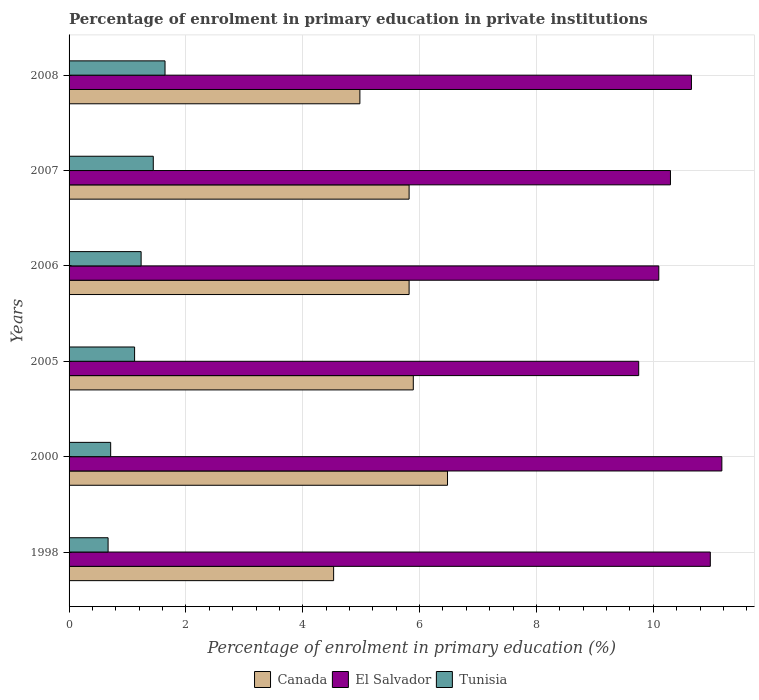How many different coloured bars are there?
Make the answer very short. 3. How many groups of bars are there?
Offer a terse response. 6. Are the number of bars on each tick of the Y-axis equal?
Offer a very short reply. Yes. What is the label of the 2nd group of bars from the top?
Ensure brevity in your answer.  2007. What is the percentage of enrolment in primary education in Tunisia in 2007?
Offer a terse response. 1.44. Across all years, what is the maximum percentage of enrolment in primary education in El Salvador?
Make the answer very short. 11.17. Across all years, what is the minimum percentage of enrolment in primary education in Canada?
Offer a terse response. 4.53. What is the total percentage of enrolment in primary education in El Salvador in the graph?
Make the answer very short. 62.94. What is the difference between the percentage of enrolment in primary education in Canada in 2000 and that in 2005?
Give a very brief answer. 0.59. What is the difference between the percentage of enrolment in primary education in Canada in 2006 and the percentage of enrolment in primary education in Tunisia in 2000?
Ensure brevity in your answer.  5.11. What is the average percentage of enrolment in primary education in Tunisia per year?
Your response must be concise. 1.14. In the year 2008, what is the difference between the percentage of enrolment in primary education in Tunisia and percentage of enrolment in primary education in Canada?
Make the answer very short. -3.34. What is the ratio of the percentage of enrolment in primary education in Tunisia in 1998 to that in 2007?
Keep it short and to the point. 0.46. Is the percentage of enrolment in primary education in El Salvador in 1998 less than that in 2006?
Keep it short and to the point. No. What is the difference between the highest and the second highest percentage of enrolment in primary education in Tunisia?
Your answer should be very brief. 0.2. What is the difference between the highest and the lowest percentage of enrolment in primary education in Canada?
Make the answer very short. 1.95. In how many years, is the percentage of enrolment in primary education in Tunisia greater than the average percentage of enrolment in primary education in Tunisia taken over all years?
Make the answer very short. 3. What does the 3rd bar from the top in 2005 represents?
Provide a short and direct response. Canada. What does the 2nd bar from the bottom in 2005 represents?
Your answer should be very brief. El Salvador. How many bars are there?
Keep it short and to the point. 18. Does the graph contain any zero values?
Offer a terse response. No. Where does the legend appear in the graph?
Provide a succinct answer. Bottom center. How are the legend labels stacked?
Give a very brief answer. Horizontal. What is the title of the graph?
Provide a succinct answer. Percentage of enrolment in primary education in private institutions. What is the label or title of the X-axis?
Make the answer very short. Percentage of enrolment in primary education (%). What is the Percentage of enrolment in primary education (%) in Canada in 1998?
Make the answer very short. 4.53. What is the Percentage of enrolment in primary education (%) in El Salvador in 1998?
Offer a terse response. 10.98. What is the Percentage of enrolment in primary education (%) in Tunisia in 1998?
Your answer should be compact. 0.67. What is the Percentage of enrolment in primary education (%) in Canada in 2000?
Your answer should be compact. 6.48. What is the Percentage of enrolment in primary education (%) in El Salvador in 2000?
Make the answer very short. 11.17. What is the Percentage of enrolment in primary education (%) of Tunisia in 2000?
Make the answer very short. 0.71. What is the Percentage of enrolment in primary education (%) in Canada in 2005?
Your answer should be compact. 5.89. What is the Percentage of enrolment in primary education (%) in El Salvador in 2005?
Provide a succinct answer. 9.75. What is the Percentage of enrolment in primary education (%) of Tunisia in 2005?
Your answer should be compact. 1.12. What is the Percentage of enrolment in primary education (%) of Canada in 2006?
Keep it short and to the point. 5.82. What is the Percentage of enrolment in primary education (%) in El Salvador in 2006?
Make the answer very short. 10.09. What is the Percentage of enrolment in primary education (%) in Tunisia in 2006?
Your answer should be compact. 1.23. What is the Percentage of enrolment in primary education (%) in Canada in 2007?
Make the answer very short. 5.82. What is the Percentage of enrolment in primary education (%) in El Salvador in 2007?
Provide a short and direct response. 10.29. What is the Percentage of enrolment in primary education (%) of Tunisia in 2007?
Your response must be concise. 1.44. What is the Percentage of enrolment in primary education (%) in Canada in 2008?
Your answer should be compact. 4.98. What is the Percentage of enrolment in primary education (%) of El Salvador in 2008?
Make the answer very short. 10.65. What is the Percentage of enrolment in primary education (%) in Tunisia in 2008?
Your answer should be very brief. 1.64. Across all years, what is the maximum Percentage of enrolment in primary education (%) in Canada?
Your answer should be compact. 6.48. Across all years, what is the maximum Percentage of enrolment in primary education (%) of El Salvador?
Your response must be concise. 11.17. Across all years, what is the maximum Percentage of enrolment in primary education (%) in Tunisia?
Offer a terse response. 1.64. Across all years, what is the minimum Percentage of enrolment in primary education (%) of Canada?
Offer a very short reply. 4.53. Across all years, what is the minimum Percentage of enrolment in primary education (%) in El Salvador?
Keep it short and to the point. 9.75. Across all years, what is the minimum Percentage of enrolment in primary education (%) of Tunisia?
Provide a short and direct response. 0.67. What is the total Percentage of enrolment in primary education (%) of Canada in the graph?
Ensure brevity in your answer.  33.52. What is the total Percentage of enrolment in primary education (%) in El Salvador in the graph?
Offer a very short reply. 62.94. What is the total Percentage of enrolment in primary education (%) of Tunisia in the graph?
Your answer should be compact. 6.82. What is the difference between the Percentage of enrolment in primary education (%) of Canada in 1998 and that in 2000?
Keep it short and to the point. -1.95. What is the difference between the Percentage of enrolment in primary education (%) of El Salvador in 1998 and that in 2000?
Ensure brevity in your answer.  -0.2. What is the difference between the Percentage of enrolment in primary education (%) of Tunisia in 1998 and that in 2000?
Provide a short and direct response. -0.04. What is the difference between the Percentage of enrolment in primary education (%) in Canada in 1998 and that in 2005?
Make the answer very short. -1.36. What is the difference between the Percentage of enrolment in primary education (%) in El Salvador in 1998 and that in 2005?
Your answer should be compact. 1.23. What is the difference between the Percentage of enrolment in primary education (%) in Tunisia in 1998 and that in 2005?
Offer a terse response. -0.45. What is the difference between the Percentage of enrolment in primary education (%) of Canada in 1998 and that in 2006?
Offer a very short reply. -1.29. What is the difference between the Percentage of enrolment in primary education (%) in El Salvador in 1998 and that in 2006?
Keep it short and to the point. 0.88. What is the difference between the Percentage of enrolment in primary education (%) of Tunisia in 1998 and that in 2006?
Offer a terse response. -0.57. What is the difference between the Percentage of enrolment in primary education (%) of Canada in 1998 and that in 2007?
Offer a terse response. -1.29. What is the difference between the Percentage of enrolment in primary education (%) in El Salvador in 1998 and that in 2007?
Your answer should be compact. 0.68. What is the difference between the Percentage of enrolment in primary education (%) in Tunisia in 1998 and that in 2007?
Keep it short and to the point. -0.77. What is the difference between the Percentage of enrolment in primary education (%) in Canada in 1998 and that in 2008?
Ensure brevity in your answer.  -0.45. What is the difference between the Percentage of enrolment in primary education (%) in El Salvador in 1998 and that in 2008?
Your response must be concise. 0.32. What is the difference between the Percentage of enrolment in primary education (%) in Tunisia in 1998 and that in 2008?
Make the answer very short. -0.97. What is the difference between the Percentage of enrolment in primary education (%) of Canada in 2000 and that in 2005?
Provide a succinct answer. 0.59. What is the difference between the Percentage of enrolment in primary education (%) of El Salvador in 2000 and that in 2005?
Your answer should be very brief. 1.42. What is the difference between the Percentage of enrolment in primary education (%) in Tunisia in 2000 and that in 2005?
Give a very brief answer. -0.41. What is the difference between the Percentage of enrolment in primary education (%) of Canada in 2000 and that in 2006?
Your answer should be very brief. 0.66. What is the difference between the Percentage of enrolment in primary education (%) of El Salvador in 2000 and that in 2006?
Give a very brief answer. 1.08. What is the difference between the Percentage of enrolment in primary education (%) of Tunisia in 2000 and that in 2006?
Provide a succinct answer. -0.52. What is the difference between the Percentage of enrolment in primary education (%) of Canada in 2000 and that in 2007?
Offer a terse response. 0.66. What is the difference between the Percentage of enrolment in primary education (%) in El Salvador in 2000 and that in 2007?
Your answer should be very brief. 0.88. What is the difference between the Percentage of enrolment in primary education (%) of Tunisia in 2000 and that in 2007?
Provide a short and direct response. -0.73. What is the difference between the Percentage of enrolment in primary education (%) in Canada in 2000 and that in 2008?
Make the answer very short. 1.5. What is the difference between the Percentage of enrolment in primary education (%) of El Salvador in 2000 and that in 2008?
Your answer should be very brief. 0.52. What is the difference between the Percentage of enrolment in primary education (%) in Tunisia in 2000 and that in 2008?
Give a very brief answer. -0.93. What is the difference between the Percentage of enrolment in primary education (%) of Canada in 2005 and that in 2006?
Your response must be concise. 0.07. What is the difference between the Percentage of enrolment in primary education (%) of El Salvador in 2005 and that in 2006?
Provide a short and direct response. -0.34. What is the difference between the Percentage of enrolment in primary education (%) in Tunisia in 2005 and that in 2006?
Keep it short and to the point. -0.11. What is the difference between the Percentage of enrolment in primary education (%) in Canada in 2005 and that in 2007?
Provide a succinct answer. 0.07. What is the difference between the Percentage of enrolment in primary education (%) of El Salvador in 2005 and that in 2007?
Give a very brief answer. -0.54. What is the difference between the Percentage of enrolment in primary education (%) in Tunisia in 2005 and that in 2007?
Offer a terse response. -0.32. What is the difference between the Percentage of enrolment in primary education (%) of Canada in 2005 and that in 2008?
Give a very brief answer. 0.91. What is the difference between the Percentage of enrolment in primary education (%) of El Salvador in 2005 and that in 2008?
Provide a succinct answer. -0.9. What is the difference between the Percentage of enrolment in primary education (%) of Tunisia in 2005 and that in 2008?
Give a very brief answer. -0.52. What is the difference between the Percentage of enrolment in primary education (%) in El Salvador in 2006 and that in 2007?
Ensure brevity in your answer.  -0.2. What is the difference between the Percentage of enrolment in primary education (%) of Tunisia in 2006 and that in 2007?
Provide a short and direct response. -0.21. What is the difference between the Percentage of enrolment in primary education (%) in Canada in 2006 and that in 2008?
Your response must be concise. 0.84. What is the difference between the Percentage of enrolment in primary education (%) of El Salvador in 2006 and that in 2008?
Your answer should be very brief. -0.56. What is the difference between the Percentage of enrolment in primary education (%) in Tunisia in 2006 and that in 2008?
Make the answer very short. -0.41. What is the difference between the Percentage of enrolment in primary education (%) in Canada in 2007 and that in 2008?
Your response must be concise. 0.84. What is the difference between the Percentage of enrolment in primary education (%) of El Salvador in 2007 and that in 2008?
Offer a very short reply. -0.36. What is the difference between the Percentage of enrolment in primary education (%) of Tunisia in 2007 and that in 2008?
Your answer should be compact. -0.2. What is the difference between the Percentage of enrolment in primary education (%) of Canada in 1998 and the Percentage of enrolment in primary education (%) of El Salvador in 2000?
Offer a terse response. -6.65. What is the difference between the Percentage of enrolment in primary education (%) in Canada in 1998 and the Percentage of enrolment in primary education (%) in Tunisia in 2000?
Provide a short and direct response. 3.82. What is the difference between the Percentage of enrolment in primary education (%) in El Salvador in 1998 and the Percentage of enrolment in primary education (%) in Tunisia in 2000?
Your answer should be compact. 10.26. What is the difference between the Percentage of enrolment in primary education (%) of Canada in 1998 and the Percentage of enrolment in primary education (%) of El Salvador in 2005?
Offer a terse response. -5.22. What is the difference between the Percentage of enrolment in primary education (%) of Canada in 1998 and the Percentage of enrolment in primary education (%) of Tunisia in 2005?
Provide a succinct answer. 3.41. What is the difference between the Percentage of enrolment in primary education (%) of El Salvador in 1998 and the Percentage of enrolment in primary education (%) of Tunisia in 2005?
Provide a short and direct response. 9.85. What is the difference between the Percentage of enrolment in primary education (%) of Canada in 1998 and the Percentage of enrolment in primary education (%) of El Salvador in 2006?
Provide a succinct answer. -5.57. What is the difference between the Percentage of enrolment in primary education (%) of Canada in 1998 and the Percentage of enrolment in primary education (%) of Tunisia in 2006?
Give a very brief answer. 3.29. What is the difference between the Percentage of enrolment in primary education (%) of El Salvador in 1998 and the Percentage of enrolment in primary education (%) of Tunisia in 2006?
Keep it short and to the point. 9.74. What is the difference between the Percentage of enrolment in primary education (%) of Canada in 1998 and the Percentage of enrolment in primary education (%) of El Salvador in 2007?
Offer a very short reply. -5.77. What is the difference between the Percentage of enrolment in primary education (%) in Canada in 1998 and the Percentage of enrolment in primary education (%) in Tunisia in 2007?
Your answer should be very brief. 3.09. What is the difference between the Percentage of enrolment in primary education (%) in El Salvador in 1998 and the Percentage of enrolment in primary education (%) in Tunisia in 2007?
Your answer should be very brief. 9.53. What is the difference between the Percentage of enrolment in primary education (%) of Canada in 1998 and the Percentage of enrolment in primary education (%) of El Salvador in 2008?
Make the answer very short. -6.12. What is the difference between the Percentage of enrolment in primary education (%) in Canada in 1998 and the Percentage of enrolment in primary education (%) in Tunisia in 2008?
Your response must be concise. 2.89. What is the difference between the Percentage of enrolment in primary education (%) of El Salvador in 1998 and the Percentage of enrolment in primary education (%) of Tunisia in 2008?
Provide a short and direct response. 9.33. What is the difference between the Percentage of enrolment in primary education (%) in Canada in 2000 and the Percentage of enrolment in primary education (%) in El Salvador in 2005?
Ensure brevity in your answer.  -3.27. What is the difference between the Percentage of enrolment in primary education (%) of Canada in 2000 and the Percentage of enrolment in primary education (%) of Tunisia in 2005?
Your answer should be very brief. 5.36. What is the difference between the Percentage of enrolment in primary education (%) of El Salvador in 2000 and the Percentage of enrolment in primary education (%) of Tunisia in 2005?
Your answer should be very brief. 10.05. What is the difference between the Percentage of enrolment in primary education (%) in Canada in 2000 and the Percentage of enrolment in primary education (%) in El Salvador in 2006?
Your answer should be very brief. -3.62. What is the difference between the Percentage of enrolment in primary education (%) in Canada in 2000 and the Percentage of enrolment in primary education (%) in Tunisia in 2006?
Your response must be concise. 5.24. What is the difference between the Percentage of enrolment in primary education (%) in El Salvador in 2000 and the Percentage of enrolment in primary education (%) in Tunisia in 2006?
Your answer should be very brief. 9.94. What is the difference between the Percentage of enrolment in primary education (%) in Canada in 2000 and the Percentage of enrolment in primary education (%) in El Salvador in 2007?
Your answer should be compact. -3.82. What is the difference between the Percentage of enrolment in primary education (%) in Canada in 2000 and the Percentage of enrolment in primary education (%) in Tunisia in 2007?
Ensure brevity in your answer.  5.04. What is the difference between the Percentage of enrolment in primary education (%) of El Salvador in 2000 and the Percentage of enrolment in primary education (%) of Tunisia in 2007?
Provide a succinct answer. 9.73. What is the difference between the Percentage of enrolment in primary education (%) in Canada in 2000 and the Percentage of enrolment in primary education (%) in El Salvador in 2008?
Offer a very short reply. -4.18. What is the difference between the Percentage of enrolment in primary education (%) of Canada in 2000 and the Percentage of enrolment in primary education (%) of Tunisia in 2008?
Make the answer very short. 4.84. What is the difference between the Percentage of enrolment in primary education (%) of El Salvador in 2000 and the Percentage of enrolment in primary education (%) of Tunisia in 2008?
Keep it short and to the point. 9.53. What is the difference between the Percentage of enrolment in primary education (%) of Canada in 2005 and the Percentage of enrolment in primary education (%) of El Salvador in 2006?
Offer a terse response. -4.2. What is the difference between the Percentage of enrolment in primary education (%) in Canada in 2005 and the Percentage of enrolment in primary education (%) in Tunisia in 2006?
Your response must be concise. 4.66. What is the difference between the Percentage of enrolment in primary education (%) in El Salvador in 2005 and the Percentage of enrolment in primary education (%) in Tunisia in 2006?
Provide a short and direct response. 8.52. What is the difference between the Percentage of enrolment in primary education (%) of Canada in 2005 and the Percentage of enrolment in primary education (%) of El Salvador in 2007?
Your answer should be compact. -4.4. What is the difference between the Percentage of enrolment in primary education (%) in Canada in 2005 and the Percentage of enrolment in primary education (%) in Tunisia in 2007?
Your answer should be very brief. 4.45. What is the difference between the Percentage of enrolment in primary education (%) of El Salvador in 2005 and the Percentage of enrolment in primary education (%) of Tunisia in 2007?
Provide a short and direct response. 8.31. What is the difference between the Percentage of enrolment in primary education (%) in Canada in 2005 and the Percentage of enrolment in primary education (%) in El Salvador in 2008?
Your answer should be compact. -4.76. What is the difference between the Percentage of enrolment in primary education (%) of Canada in 2005 and the Percentage of enrolment in primary education (%) of Tunisia in 2008?
Your response must be concise. 4.25. What is the difference between the Percentage of enrolment in primary education (%) in El Salvador in 2005 and the Percentage of enrolment in primary education (%) in Tunisia in 2008?
Make the answer very short. 8.11. What is the difference between the Percentage of enrolment in primary education (%) in Canada in 2006 and the Percentage of enrolment in primary education (%) in El Salvador in 2007?
Your response must be concise. -4.47. What is the difference between the Percentage of enrolment in primary education (%) of Canada in 2006 and the Percentage of enrolment in primary education (%) of Tunisia in 2007?
Keep it short and to the point. 4.38. What is the difference between the Percentage of enrolment in primary education (%) of El Salvador in 2006 and the Percentage of enrolment in primary education (%) of Tunisia in 2007?
Provide a short and direct response. 8.65. What is the difference between the Percentage of enrolment in primary education (%) in Canada in 2006 and the Percentage of enrolment in primary education (%) in El Salvador in 2008?
Provide a succinct answer. -4.83. What is the difference between the Percentage of enrolment in primary education (%) of Canada in 2006 and the Percentage of enrolment in primary education (%) of Tunisia in 2008?
Give a very brief answer. 4.18. What is the difference between the Percentage of enrolment in primary education (%) of El Salvador in 2006 and the Percentage of enrolment in primary education (%) of Tunisia in 2008?
Provide a succinct answer. 8.45. What is the difference between the Percentage of enrolment in primary education (%) of Canada in 2007 and the Percentage of enrolment in primary education (%) of El Salvador in 2008?
Your answer should be very brief. -4.83. What is the difference between the Percentage of enrolment in primary education (%) of Canada in 2007 and the Percentage of enrolment in primary education (%) of Tunisia in 2008?
Your response must be concise. 4.18. What is the difference between the Percentage of enrolment in primary education (%) of El Salvador in 2007 and the Percentage of enrolment in primary education (%) of Tunisia in 2008?
Make the answer very short. 8.65. What is the average Percentage of enrolment in primary education (%) in Canada per year?
Keep it short and to the point. 5.59. What is the average Percentage of enrolment in primary education (%) in El Salvador per year?
Provide a succinct answer. 10.49. What is the average Percentage of enrolment in primary education (%) in Tunisia per year?
Make the answer very short. 1.14. In the year 1998, what is the difference between the Percentage of enrolment in primary education (%) of Canada and Percentage of enrolment in primary education (%) of El Salvador?
Offer a terse response. -6.45. In the year 1998, what is the difference between the Percentage of enrolment in primary education (%) of Canada and Percentage of enrolment in primary education (%) of Tunisia?
Give a very brief answer. 3.86. In the year 1998, what is the difference between the Percentage of enrolment in primary education (%) in El Salvador and Percentage of enrolment in primary education (%) in Tunisia?
Give a very brief answer. 10.31. In the year 2000, what is the difference between the Percentage of enrolment in primary education (%) of Canada and Percentage of enrolment in primary education (%) of El Salvador?
Provide a succinct answer. -4.7. In the year 2000, what is the difference between the Percentage of enrolment in primary education (%) of Canada and Percentage of enrolment in primary education (%) of Tunisia?
Your answer should be compact. 5.77. In the year 2000, what is the difference between the Percentage of enrolment in primary education (%) of El Salvador and Percentage of enrolment in primary education (%) of Tunisia?
Provide a short and direct response. 10.46. In the year 2005, what is the difference between the Percentage of enrolment in primary education (%) in Canada and Percentage of enrolment in primary education (%) in El Salvador?
Ensure brevity in your answer.  -3.86. In the year 2005, what is the difference between the Percentage of enrolment in primary education (%) in Canada and Percentage of enrolment in primary education (%) in Tunisia?
Your response must be concise. 4.77. In the year 2005, what is the difference between the Percentage of enrolment in primary education (%) of El Salvador and Percentage of enrolment in primary education (%) of Tunisia?
Keep it short and to the point. 8.63. In the year 2006, what is the difference between the Percentage of enrolment in primary education (%) in Canada and Percentage of enrolment in primary education (%) in El Salvador?
Ensure brevity in your answer.  -4.27. In the year 2006, what is the difference between the Percentage of enrolment in primary education (%) of Canada and Percentage of enrolment in primary education (%) of Tunisia?
Offer a very short reply. 4.59. In the year 2006, what is the difference between the Percentage of enrolment in primary education (%) in El Salvador and Percentage of enrolment in primary education (%) in Tunisia?
Your response must be concise. 8.86. In the year 2007, what is the difference between the Percentage of enrolment in primary education (%) of Canada and Percentage of enrolment in primary education (%) of El Salvador?
Offer a terse response. -4.47. In the year 2007, what is the difference between the Percentage of enrolment in primary education (%) in Canada and Percentage of enrolment in primary education (%) in Tunisia?
Your response must be concise. 4.38. In the year 2007, what is the difference between the Percentage of enrolment in primary education (%) in El Salvador and Percentage of enrolment in primary education (%) in Tunisia?
Your response must be concise. 8.85. In the year 2008, what is the difference between the Percentage of enrolment in primary education (%) in Canada and Percentage of enrolment in primary education (%) in El Salvador?
Offer a very short reply. -5.68. In the year 2008, what is the difference between the Percentage of enrolment in primary education (%) in Canada and Percentage of enrolment in primary education (%) in Tunisia?
Provide a short and direct response. 3.34. In the year 2008, what is the difference between the Percentage of enrolment in primary education (%) of El Salvador and Percentage of enrolment in primary education (%) of Tunisia?
Give a very brief answer. 9.01. What is the ratio of the Percentage of enrolment in primary education (%) in Canada in 1998 to that in 2000?
Provide a short and direct response. 0.7. What is the ratio of the Percentage of enrolment in primary education (%) of El Salvador in 1998 to that in 2000?
Offer a very short reply. 0.98. What is the ratio of the Percentage of enrolment in primary education (%) in Tunisia in 1998 to that in 2000?
Your response must be concise. 0.94. What is the ratio of the Percentage of enrolment in primary education (%) of Canada in 1998 to that in 2005?
Your answer should be compact. 0.77. What is the ratio of the Percentage of enrolment in primary education (%) of El Salvador in 1998 to that in 2005?
Provide a succinct answer. 1.13. What is the ratio of the Percentage of enrolment in primary education (%) of Tunisia in 1998 to that in 2005?
Offer a terse response. 0.6. What is the ratio of the Percentage of enrolment in primary education (%) in Canada in 1998 to that in 2006?
Your response must be concise. 0.78. What is the ratio of the Percentage of enrolment in primary education (%) of El Salvador in 1998 to that in 2006?
Offer a terse response. 1.09. What is the ratio of the Percentage of enrolment in primary education (%) in Tunisia in 1998 to that in 2006?
Provide a short and direct response. 0.54. What is the ratio of the Percentage of enrolment in primary education (%) in Canada in 1998 to that in 2007?
Your answer should be compact. 0.78. What is the ratio of the Percentage of enrolment in primary education (%) of El Salvador in 1998 to that in 2007?
Your answer should be very brief. 1.07. What is the ratio of the Percentage of enrolment in primary education (%) of Tunisia in 1998 to that in 2007?
Make the answer very short. 0.46. What is the ratio of the Percentage of enrolment in primary education (%) of Canada in 1998 to that in 2008?
Offer a very short reply. 0.91. What is the ratio of the Percentage of enrolment in primary education (%) of El Salvador in 1998 to that in 2008?
Keep it short and to the point. 1.03. What is the ratio of the Percentage of enrolment in primary education (%) of Tunisia in 1998 to that in 2008?
Keep it short and to the point. 0.41. What is the ratio of the Percentage of enrolment in primary education (%) in Canada in 2000 to that in 2005?
Offer a terse response. 1.1. What is the ratio of the Percentage of enrolment in primary education (%) of El Salvador in 2000 to that in 2005?
Make the answer very short. 1.15. What is the ratio of the Percentage of enrolment in primary education (%) of Tunisia in 2000 to that in 2005?
Provide a short and direct response. 0.63. What is the ratio of the Percentage of enrolment in primary education (%) in Canada in 2000 to that in 2006?
Make the answer very short. 1.11. What is the ratio of the Percentage of enrolment in primary education (%) in El Salvador in 2000 to that in 2006?
Provide a succinct answer. 1.11. What is the ratio of the Percentage of enrolment in primary education (%) of Tunisia in 2000 to that in 2006?
Give a very brief answer. 0.58. What is the ratio of the Percentage of enrolment in primary education (%) in Canada in 2000 to that in 2007?
Your answer should be compact. 1.11. What is the ratio of the Percentage of enrolment in primary education (%) of El Salvador in 2000 to that in 2007?
Make the answer very short. 1.09. What is the ratio of the Percentage of enrolment in primary education (%) of Tunisia in 2000 to that in 2007?
Your response must be concise. 0.49. What is the ratio of the Percentage of enrolment in primary education (%) in Canada in 2000 to that in 2008?
Ensure brevity in your answer.  1.3. What is the ratio of the Percentage of enrolment in primary education (%) in El Salvador in 2000 to that in 2008?
Provide a succinct answer. 1.05. What is the ratio of the Percentage of enrolment in primary education (%) in Tunisia in 2000 to that in 2008?
Your answer should be compact. 0.43. What is the ratio of the Percentage of enrolment in primary education (%) of Canada in 2005 to that in 2006?
Offer a terse response. 1.01. What is the ratio of the Percentage of enrolment in primary education (%) of El Salvador in 2005 to that in 2006?
Make the answer very short. 0.97. What is the ratio of the Percentage of enrolment in primary education (%) in Tunisia in 2005 to that in 2006?
Provide a short and direct response. 0.91. What is the ratio of the Percentage of enrolment in primary education (%) in Canada in 2005 to that in 2007?
Your answer should be very brief. 1.01. What is the ratio of the Percentage of enrolment in primary education (%) in El Salvador in 2005 to that in 2007?
Give a very brief answer. 0.95. What is the ratio of the Percentage of enrolment in primary education (%) in Tunisia in 2005 to that in 2007?
Give a very brief answer. 0.78. What is the ratio of the Percentage of enrolment in primary education (%) in Canada in 2005 to that in 2008?
Keep it short and to the point. 1.18. What is the ratio of the Percentage of enrolment in primary education (%) in El Salvador in 2005 to that in 2008?
Your response must be concise. 0.92. What is the ratio of the Percentage of enrolment in primary education (%) in Tunisia in 2005 to that in 2008?
Your response must be concise. 0.68. What is the ratio of the Percentage of enrolment in primary education (%) of Canada in 2006 to that in 2007?
Give a very brief answer. 1. What is the ratio of the Percentage of enrolment in primary education (%) in El Salvador in 2006 to that in 2007?
Your answer should be compact. 0.98. What is the ratio of the Percentage of enrolment in primary education (%) of Tunisia in 2006 to that in 2007?
Ensure brevity in your answer.  0.86. What is the ratio of the Percentage of enrolment in primary education (%) in Canada in 2006 to that in 2008?
Ensure brevity in your answer.  1.17. What is the ratio of the Percentage of enrolment in primary education (%) of El Salvador in 2006 to that in 2008?
Provide a short and direct response. 0.95. What is the ratio of the Percentage of enrolment in primary education (%) of Tunisia in 2006 to that in 2008?
Make the answer very short. 0.75. What is the ratio of the Percentage of enrolment in primary education (%) of Canada in 2007 to that in 2008?
Offer a terse response. 1.17. What is the ratio of the Percentage of enrolment in primary education (%) of El Salvador in 2007 to that in 2008?
Offer a very short reply. 0.97. What is the ratio of the Percentage of enrolment in primary education (%) of Tunisia in 2007 to that in 2008?
Offer a terse response. 0.88. What is the difference between the highest and the second highest Percentage of enrolment in primary education (%) of Canada?
Provide a succinct answer. 0.59. What is the difference between the highest and the second highest Percentage of enrolment in primary education (%) of El Salvador?
Give a very brief answer. 0.2. What is the difference between the highest and the second highest Percentage of enrolment in primary education (%) of Tunisia?
Keep it short and to the point. 0.2. What is the difference between the highest and the lowest Percentage of enrolment in primary education (%) in Canada?
Offer a very short reply. 1.95. What is the difference between the highest and the lowest Percentage of enrolment in primary education (%) in El Salvador?
Offer a terse response. 1.42. What is the difference between the highest and the lowest Percentage of enrolment in primary education (%) of Tunisia?
Your answer should be compact. 0.97. 